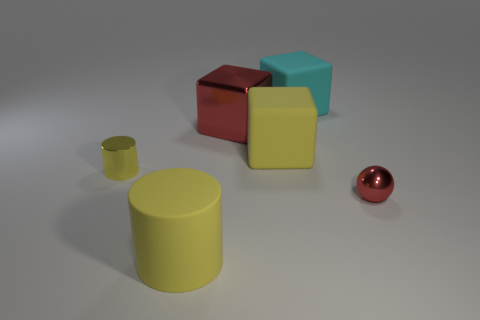How many things are either brown metal blocks or big yellow matte objects in front of the yellow block?
Offer a terse response. 1. There is a thing behind the red metallic object behind the tiny metallic object that is to the left of the yellow matte cylinder; what is it made of?
Your response must be concise. Rubber. Are there any other things that are the same material as the ball?
Make the answer very short. Yes. There is a tiny sphere in front of the yellow metallic cylinder; does it have the same color as the metal block?
Make the answer very short. Yes. How many blue objects are tiny things or large matte things?
Offer a very short reply. 0. What number of other objects are the same shape as the large metallic thing?
Provide a succinct answer. 2. Do the large cyan cube and the large cylinder have the same material?
Provide a succinct answer. Yes. There is a thing that is on the left side of the cyan block and behind the yellow block; what material is it?
Keep it short and to the point. Metal. What is the color of the shiny object that is to the left of the big cylinder?
Your response must be concise. Yellow. Are there more rubber objects that are left of the large cyan object than yellow rubber objects?
Your answer should be compact. No. 